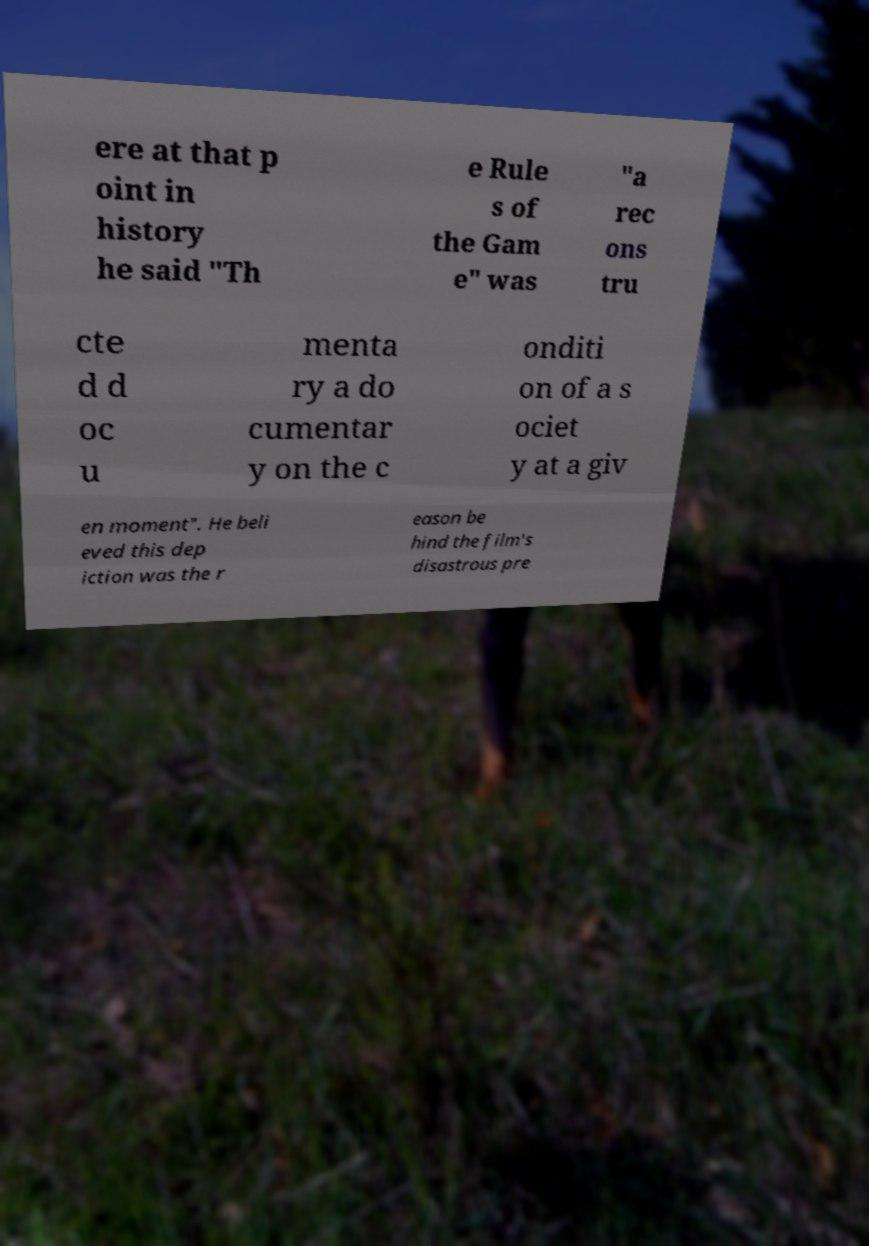Please read and relay the text visible in this image. What does it say? ere at that p oint in history he said "Th e Rule s of the Gam e" was "a rec ons tru cte d d oc u menta ry a do cumentar y on the c onditi on of a s ociet y at a giv en moment". He beli eved this dep iction was the r eason be hind the film's disastrous pre 